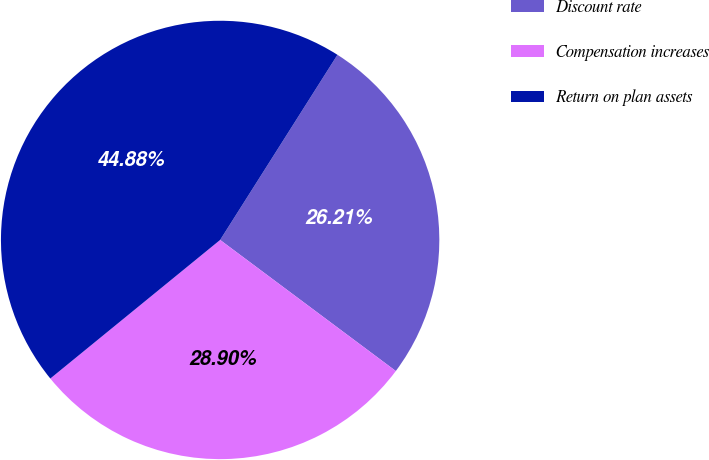Convert chart to OTSL. <chart><loc_0><loc_0><loc_500><loc_500><pie_chart><fcel>Discount rate<fcel>Compensation increases<fcel>Return on plan assets<nl><fcel>26.21%<fcel>28.9%<fcel>44.88%<nl></chart> 